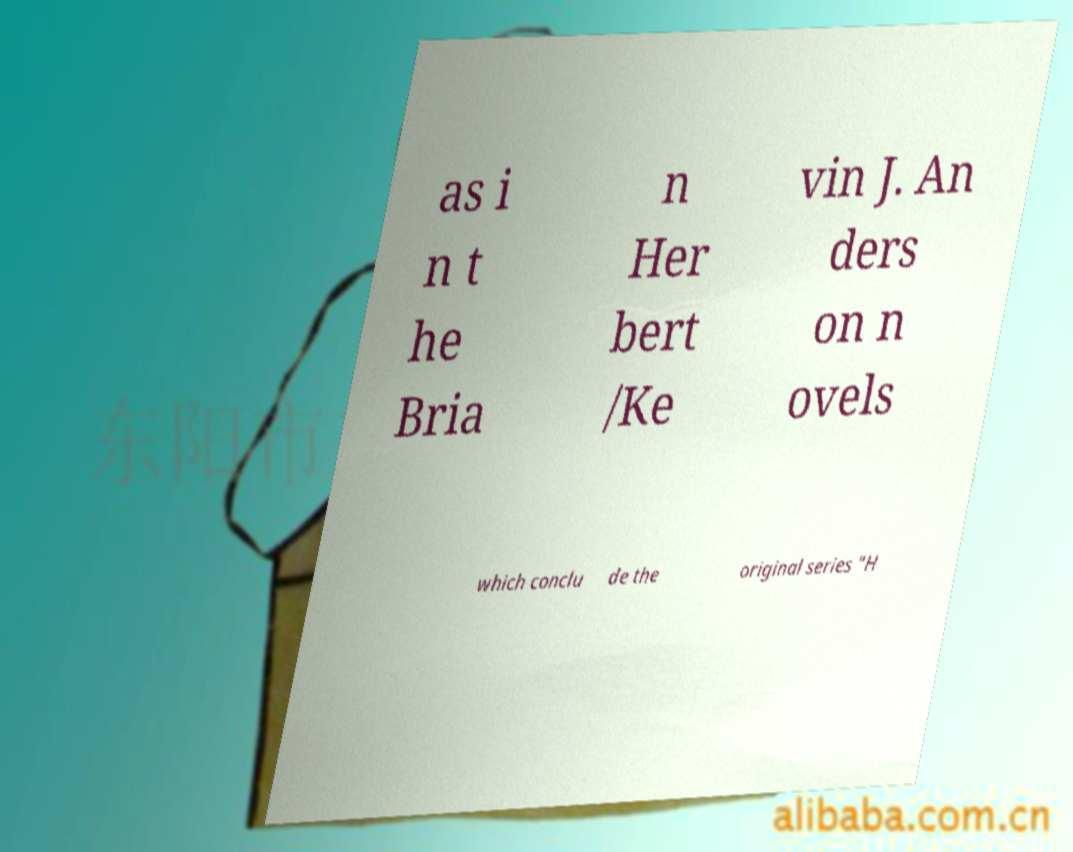Please identify and transcribe the text found in this image. as i n t he Bria n Her bert /Ke vin J. An ders on n ovels which conclu de the original series "H 